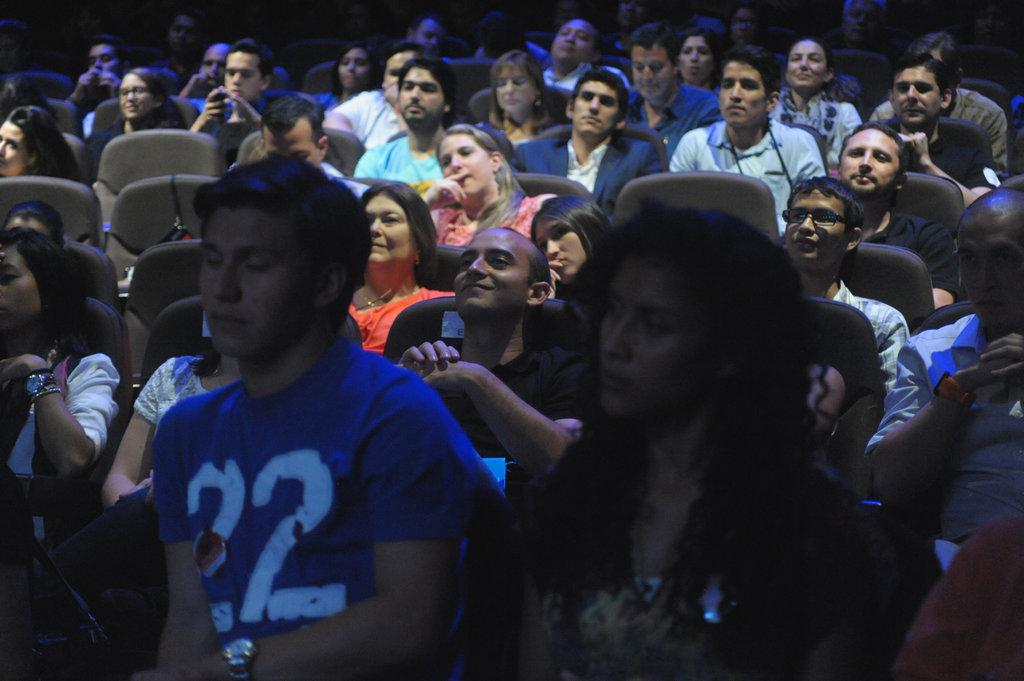How many people are present in the image? There are many people in the image. What are the people doing in the image? The people are sitting on chairs. What direction are the people looking in the image? The people are staring in the front. Where might this image have been taken? The image seems to be taken inside a theater hall. What type of road can be seen in the image? There is no road present in the image; it appears to be taken inside a theater hall. What is the purpose of the board in the image? There is no board present in the image. 